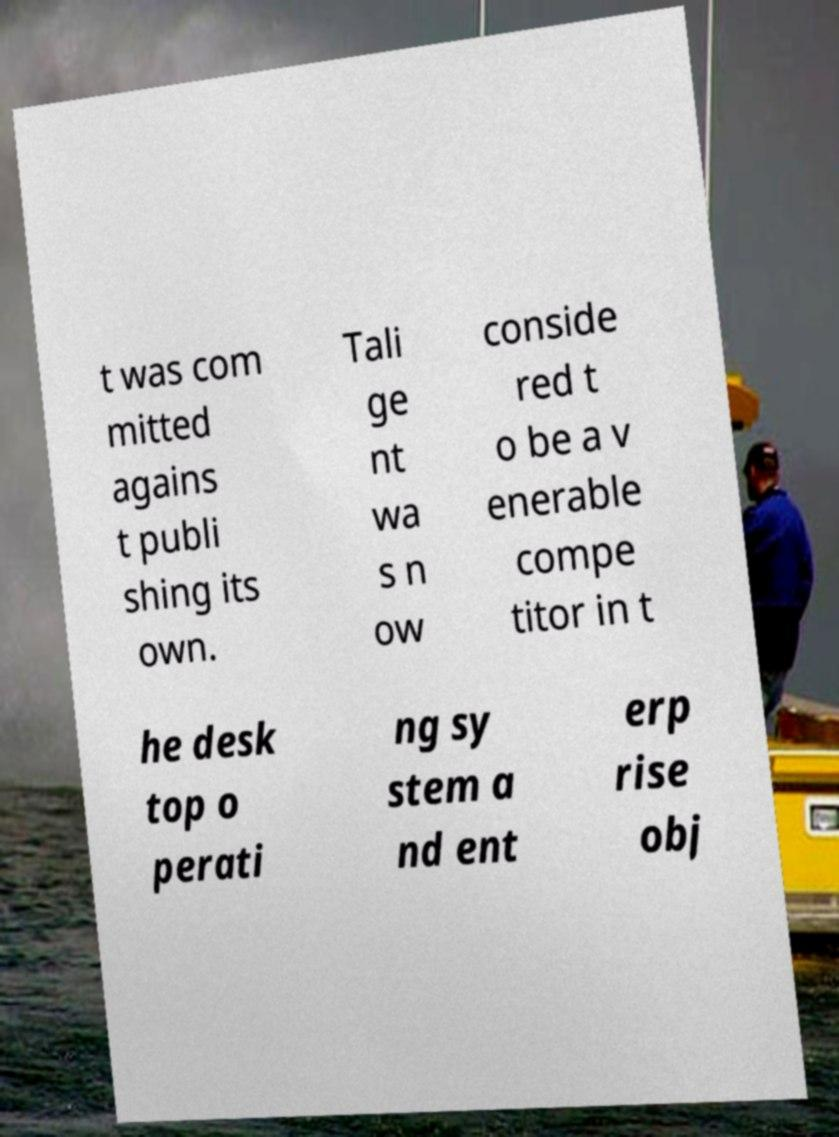Can you read and provide the text displayed in the image?This photo seems to have some interesting text. Can you extract and type it out for me? t was com mitted agains t publi shing its own. Tali ge nt wa s n ow conside red t o be a v enerable compe titor in t he desk top o perati ng sy stem a nd ent erp rise obj 